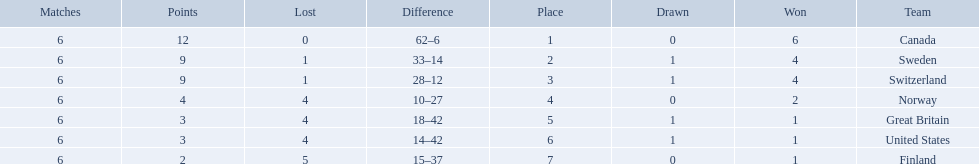What are all the teams? Canada, Sweden, Switzerland, Norway, Great Britain, United States, Finland. What were their points? 12, 9, 9, 4, 3, 3, 2. What about just switzerland and great britain? 9, 3. Now, which of those teams scored higher? Switzerland. 